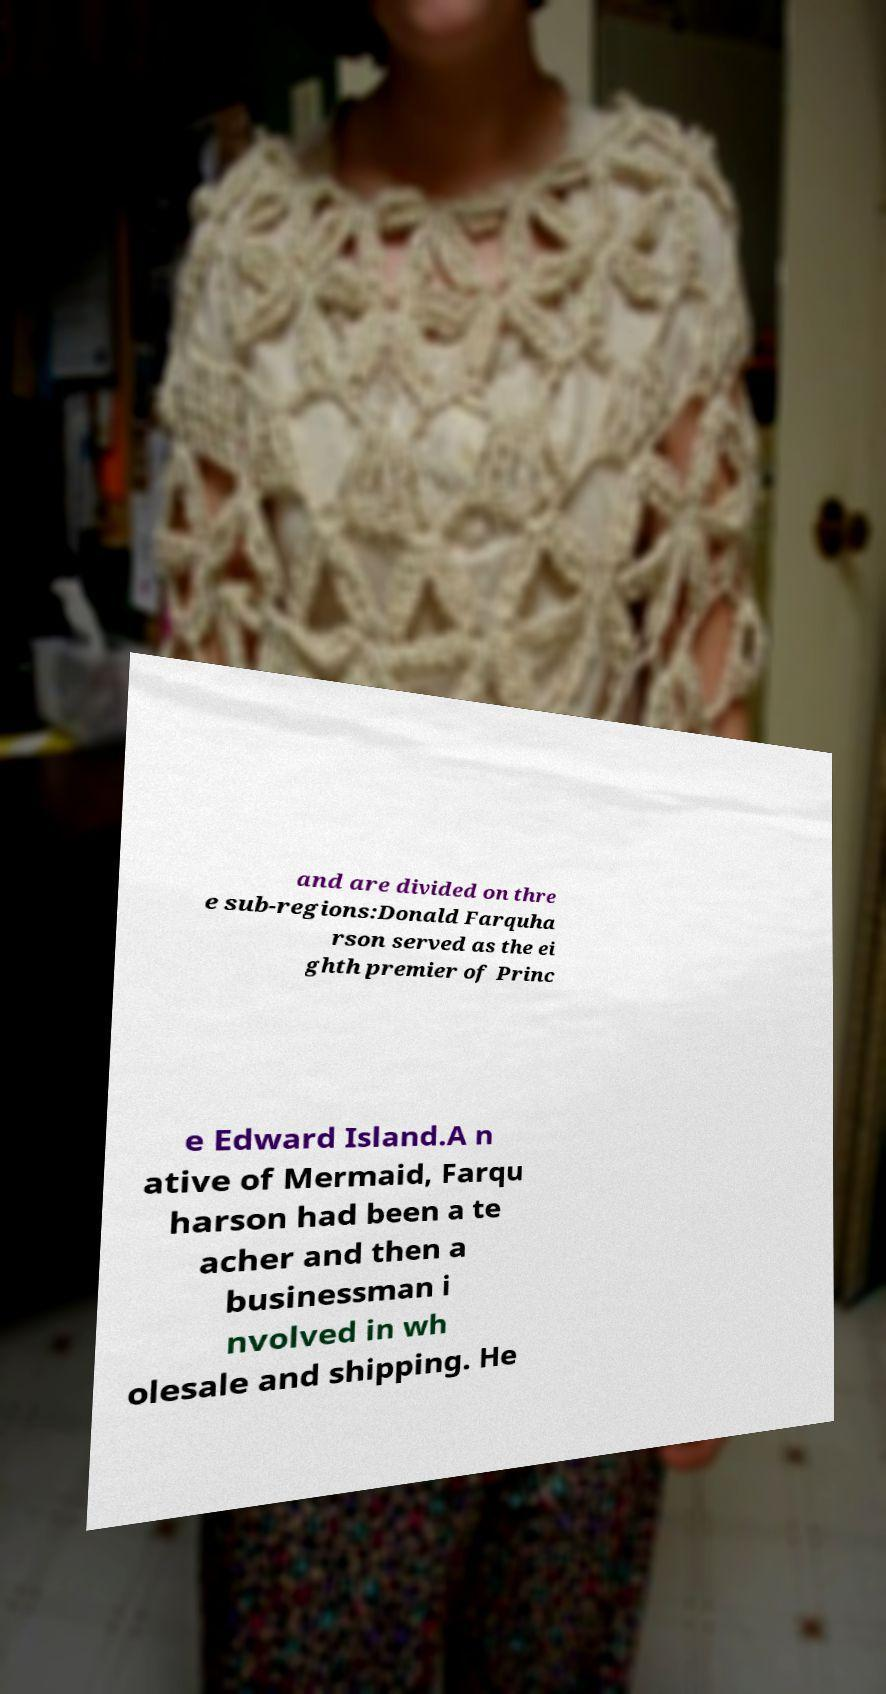I need the written content from this picture converted into text. Can you do that? and are divided on thre e sub-regions:Donald Farquha rson served as the ei ghth premier of Princ e Edward Island.A n ative of Mermaid, Farqu harson had been a te acher and then a businessman i nvolved in wh olesale and shipping. He 